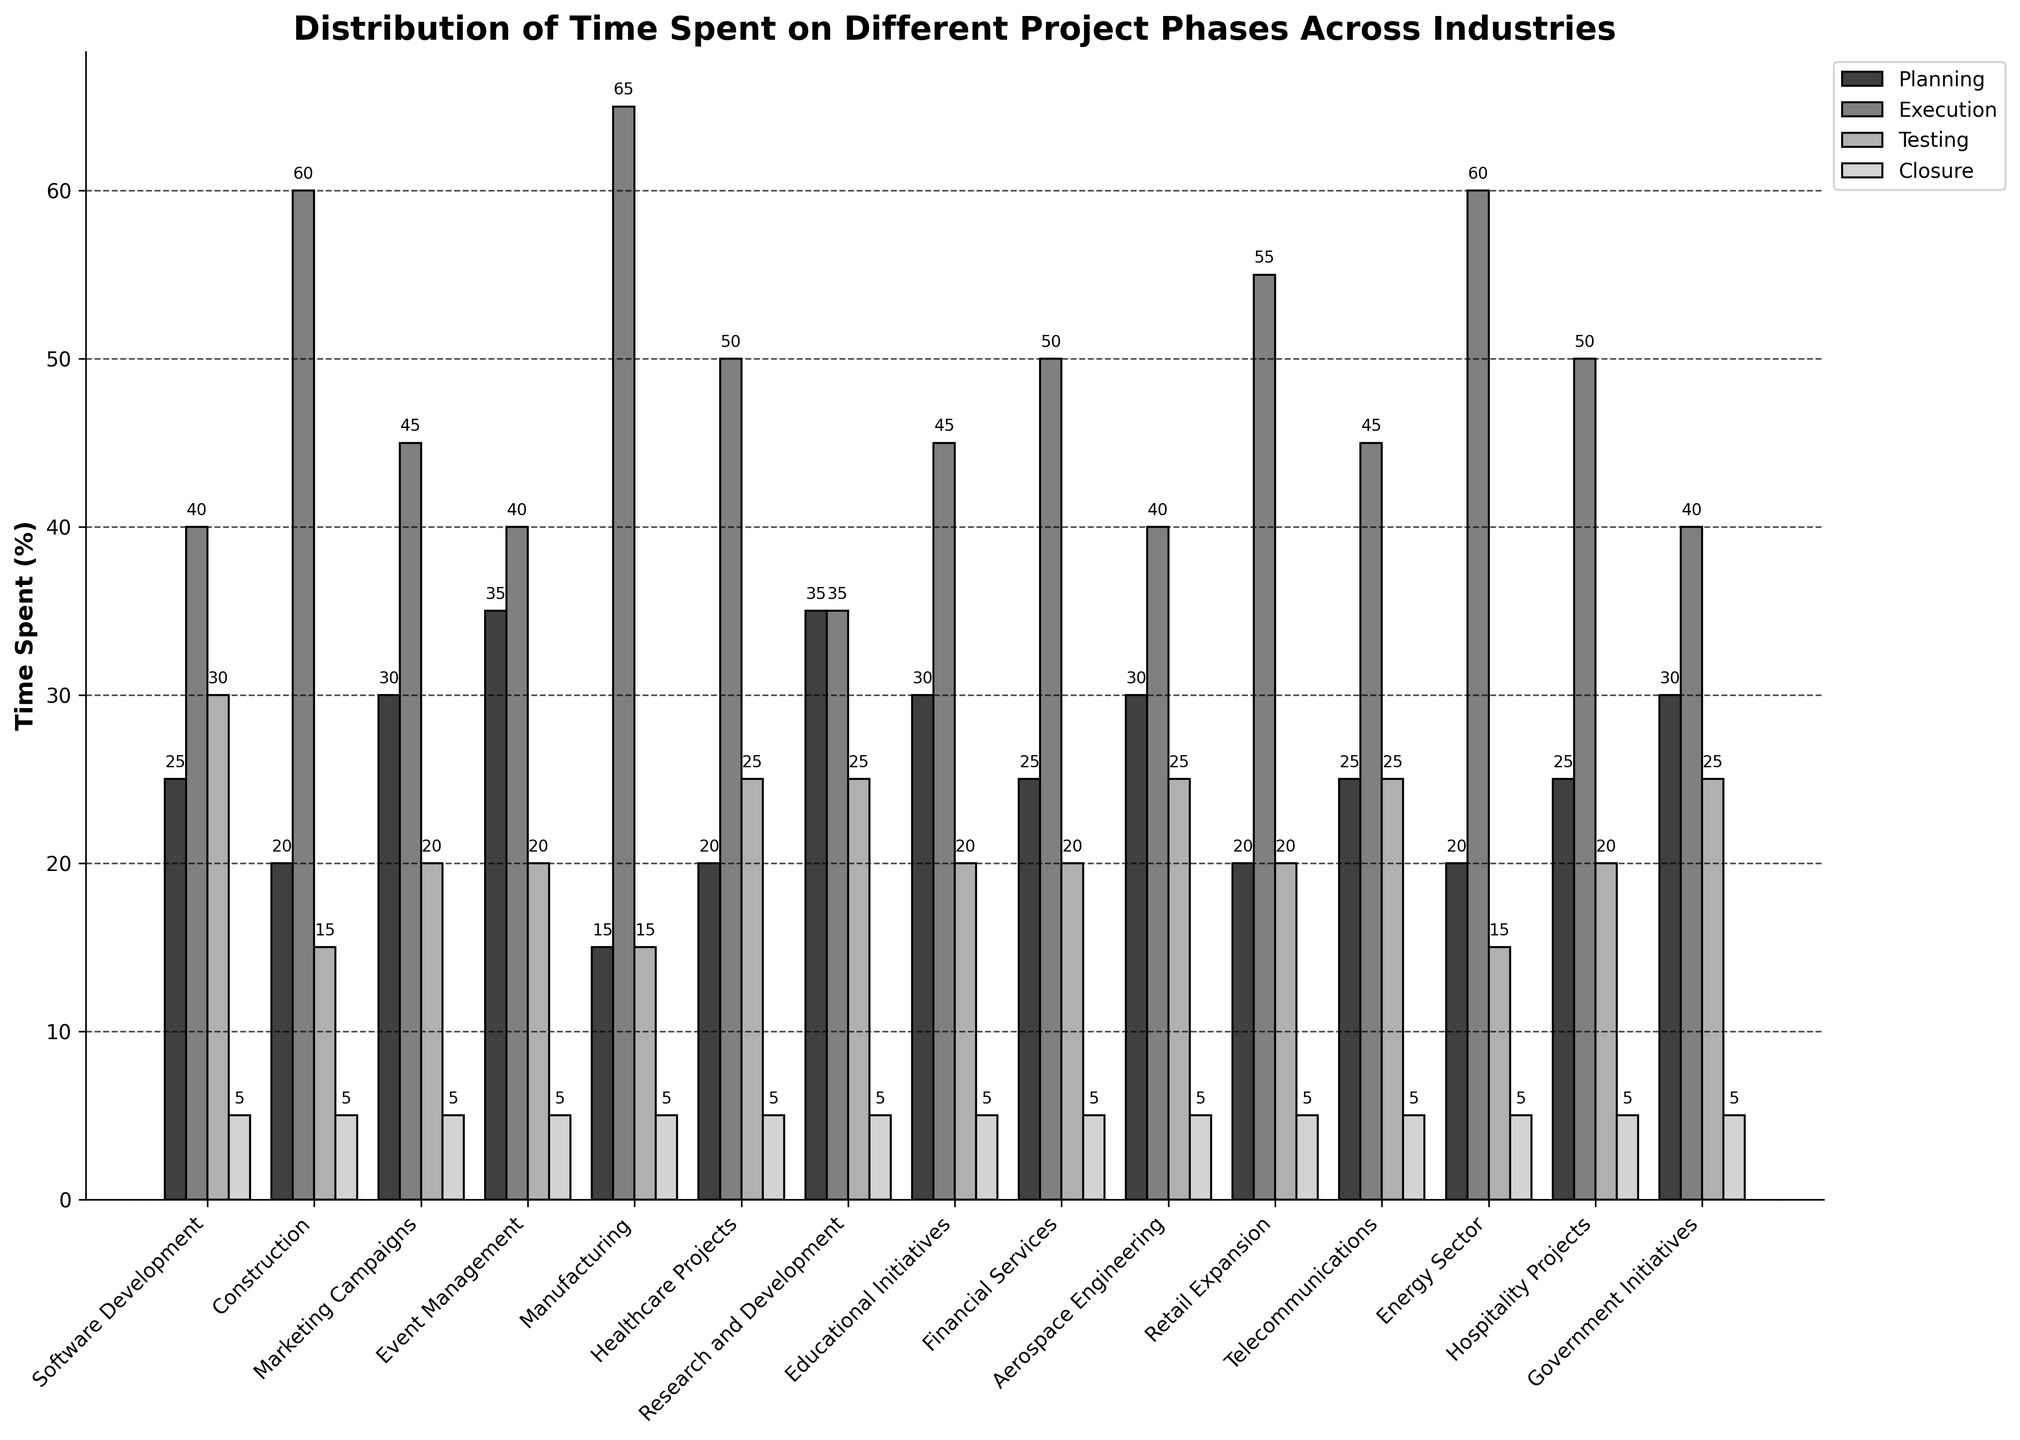Which industry spends the highest percentage of time on execution? According to the bar chart, Manufacturing has the highest percentage of time spent on the execution phase.
Answer: Manufacturing What is the total time spent on planning and testing in Financial Services? In Financial Services, the time spent on planning is 25% and on testing is 20%. The total time spent on these two phases is 25% + 20% = 45%.
Answer: 45% Compare the time spent on closure across all industries. Are they the same? By visual inspection, it appears that the closure phase uniformly accounts for 5% of the time across all industries.
Answer: Yes Which industries spend more than 60% of time in execution? The bar chart shows that Construction, Manufacturing, and Energy Sector spend more than 60% of their time in the execution phase.
Answer: Construction, Manufacturing, Energy Sector How does the time spent on planning in Event Management compare to Educational Initiatives? The bar chart indicates that Event Management spends 35% on planning, whereas Educational Initiatives spend 30% on planning. Thus, Event Management spends 5% more time on planning.
Answer: Event Management spends 5% more What is the average amount of time spent on testing across all industries? To calculate the average time spent on testing, sum up the percentage of time spent on testing for all industries and divide by the number of industries ([30 + 15 + 20 + 20 + 15 + 25 + 25 + 20 + 20 + 25 + 20 + 25 + 15 + 20 + 25] / 15 = 22%).
Answer: 22% Between Software Development and Marketing Campaigns, which industry allocates more time to the planning phase? Software Development allocates 25% of its time to planning, while Marketing Campaigns allocate 30%. Therefore, Marketing Campaigns allocate more time to the planning phase.
Answer: Marketing Campaigns Is there any industry where the time spent on execution is equal to testing? The bar chart shows that Research and Development spends an equal amount of time (35%) on both the execution and testing phases.
Answer: Research and Development Which industry spends the least amount of time in the testing phase? The bar chart illustrates that Construction, Manufacturing, and Energy Sector all spend the least amount of time in the testing phase with 15%.
Answer: Construction, Manufacturing, Energy Sector Calculate the difference in time spent on execution between Retail Expansion and Telecommunications. Retail Expansion spends 55% of time on execution while Telecommunications spends 45%. The difference is 55% - 45% = 10%.
Answer: 10% 